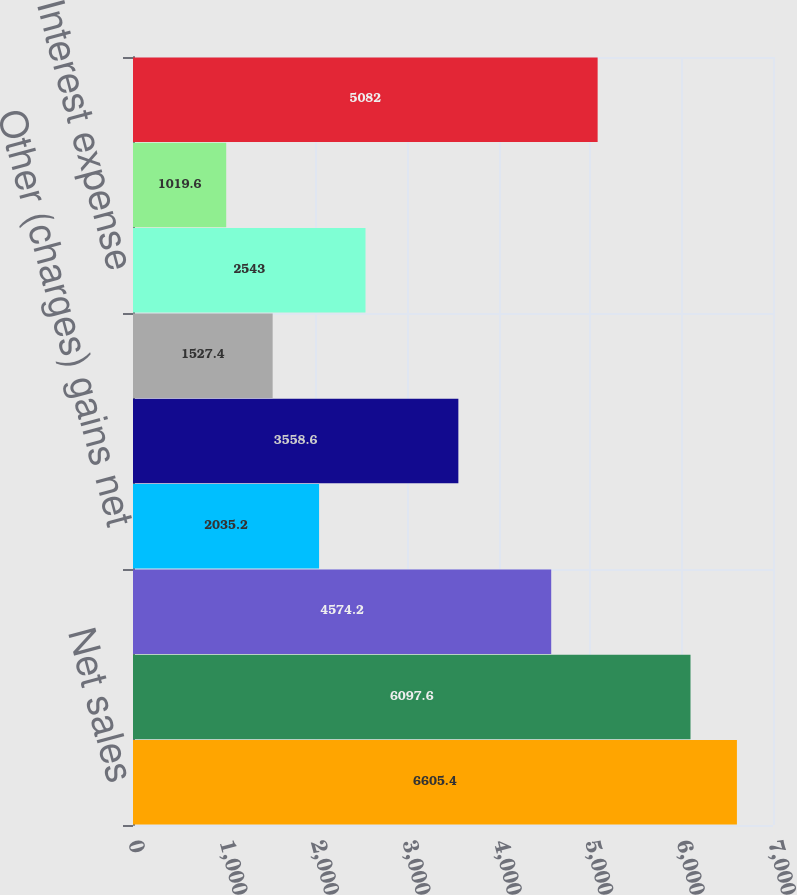<chart> <loc_0><loc_0><loc_500><loc_500><bar_chart><fcel>Net sales<fcel>Gross profit<fcel>Selling general and<fcel>Other (charges) gains net<fcel>Operating profit (loss)<fcel>Equity in net earnings of<fcel>Interest expense<fcel>Dividend income - cost<fcel>Earnings (loss) from<nl><fcel>6605.4<fcel>6097.6<fcel>4574.2<fcel>2035.2<fcel>3558.6<fcel>1527.4<fcel>2543<fcel>1019.6<fcel>5082<nl></chart> 